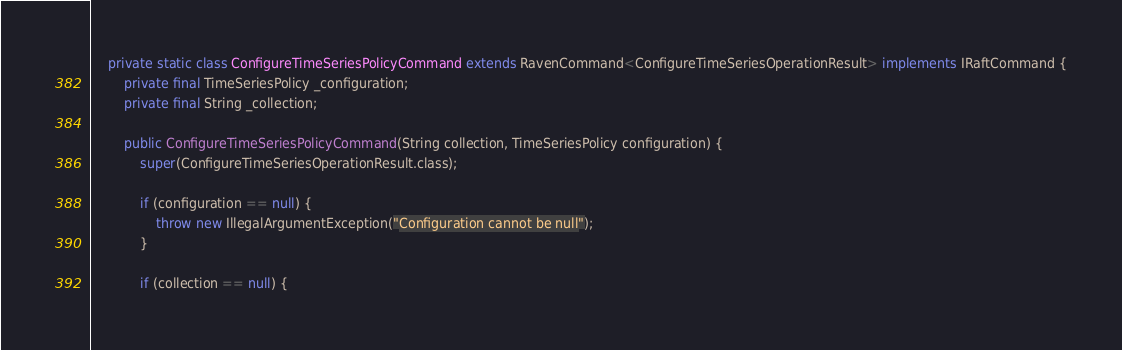<code> <loc_0><loc_0><loc_500><loc_500><_Java_>    private static class ConfigureTimeSeriesPolicyCommand extends RavenCommand<ConfigureTimeSeriesOperationResult> implements IRaftCommand {
        private final TimeSeriesPolicy _configuration;
        private final String _collection;

        public ConfigureTimeSeriesPolicyCommand(String collection, TimeSeriesPolicy configuration) {
            super(ConfigureTimeSeriesOperationResult.class);

            if (configuration == null) {
                throw new IllegalArgumentException("Configuration cannot be null");
            }

            if (collection == null) {</code> 